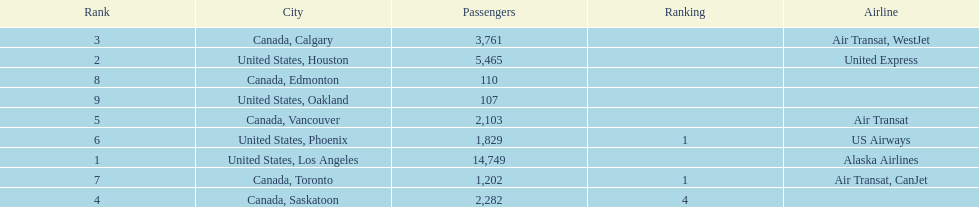How many cities from canada are on this list? 5. 